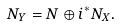Convert formula to latex. <formula><loc_0><loc_0><loc_500><loc_500>N _ { Y } = N \oplus i ^ { * } N _ { X } .</formula> 